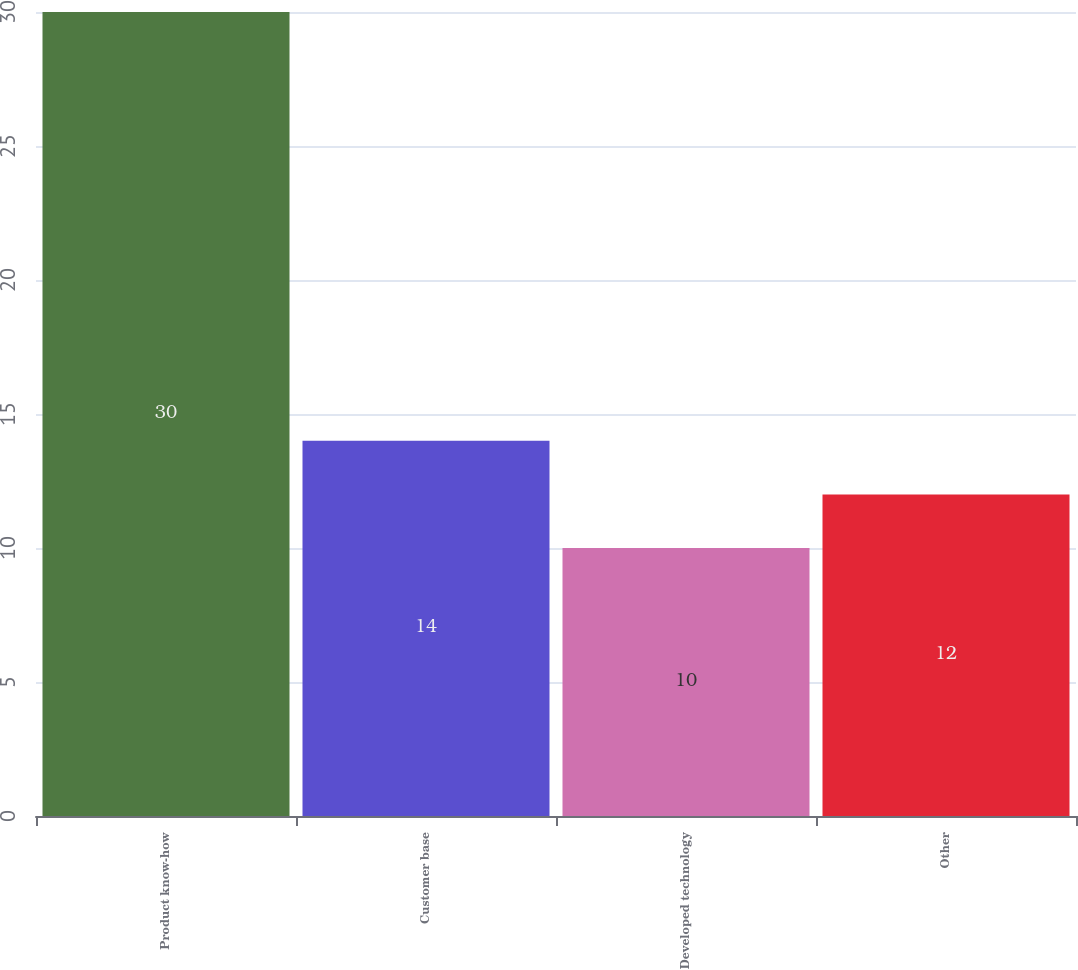Convert chart to OTSL. <chart><loc_0><loc_0><loc_500><loc_500><bar_chart><fcel>Product know-how<fcel>Customer base<fcel>Developed technology<fcel>Other<nl><fcel>30<fcel>14<fcel>10<fcel>12<nl></chart> 